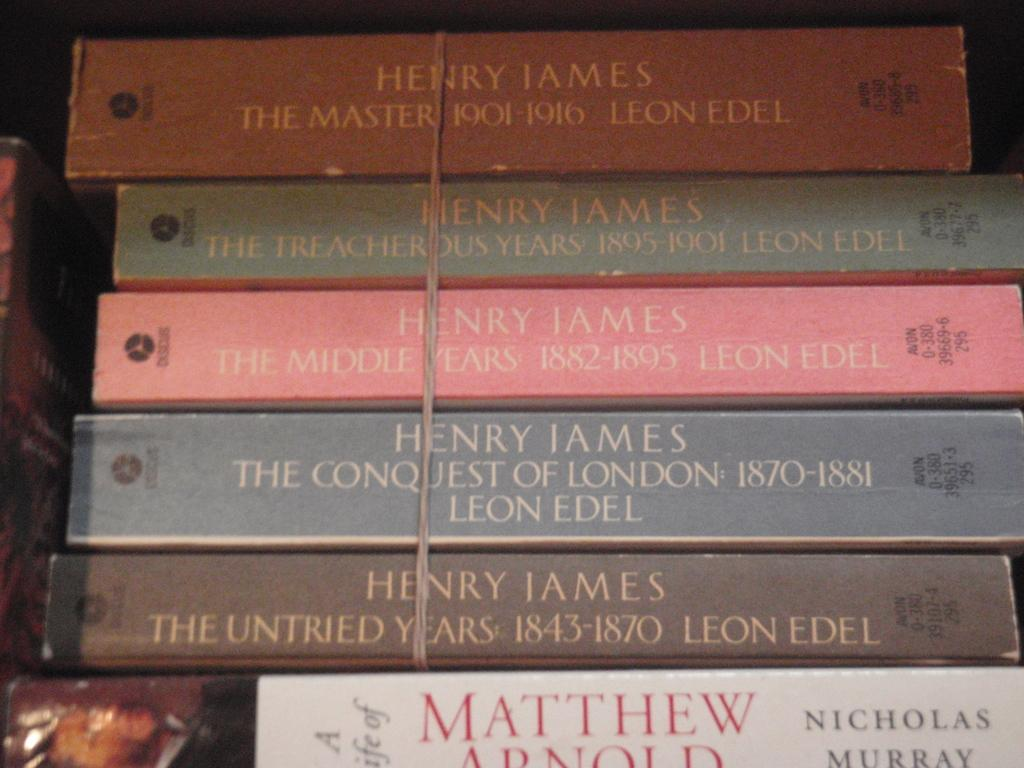Provide a one-sentence caption for the provided image. Four books by Henry James and one by Nicholas Murray. 